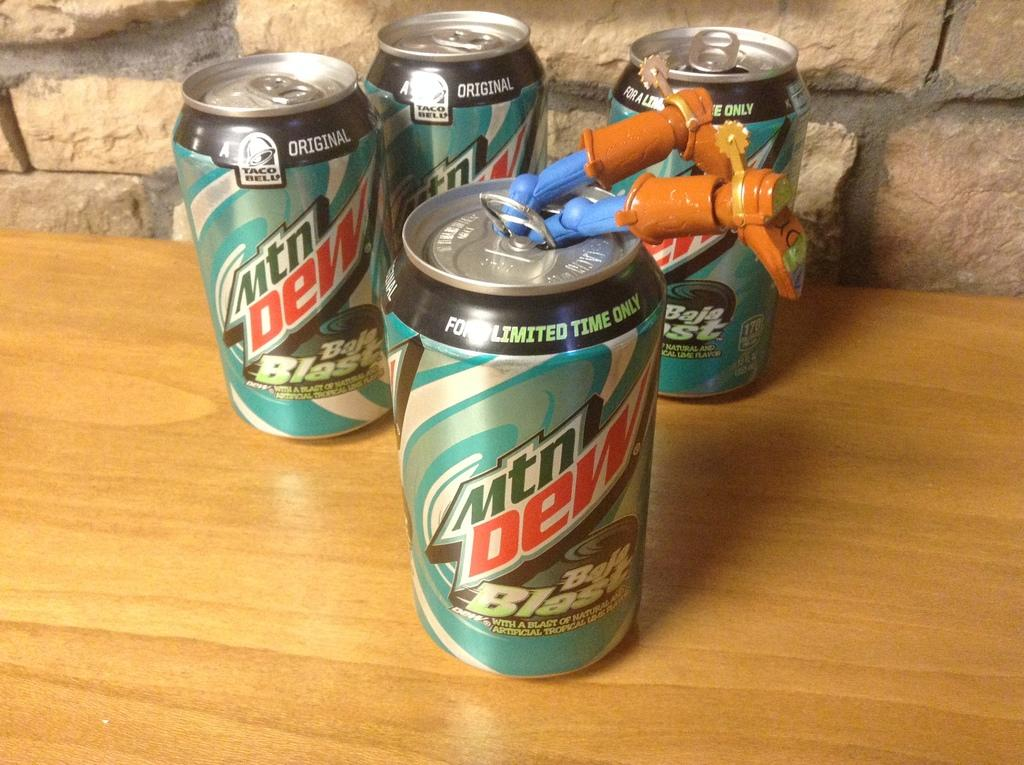<image>
Present a compact description of the photo's key features. Limited edition cans of Mtn. Dew Baja Blast with the legs of Woody from Toy Story hanging out of one. 